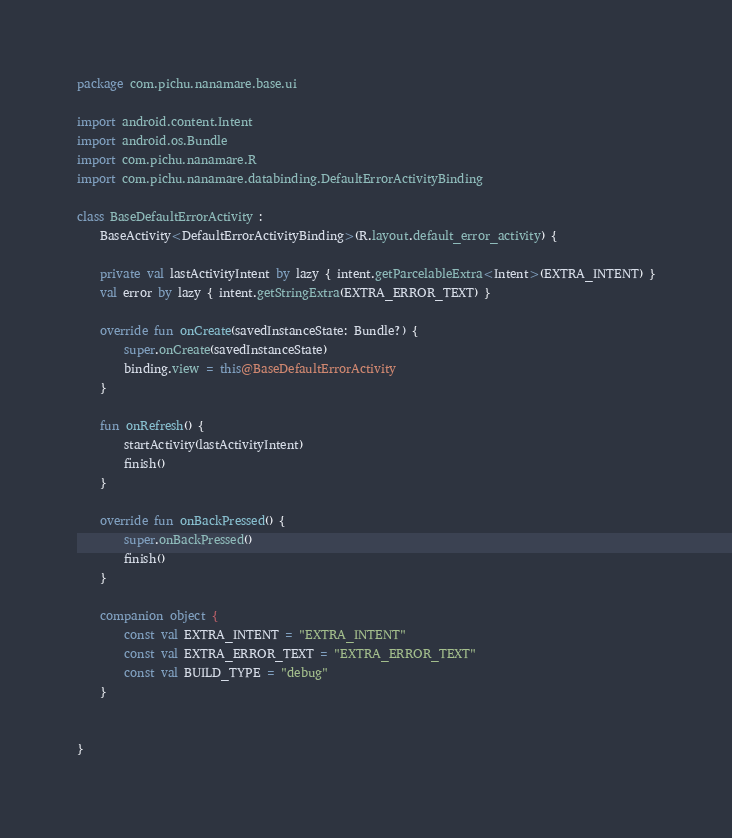<code> <loc_0><loc_0><loc_500><loc_500><_Kotlin_>package com.pichu.nanamare.base.ui

import android.content.Intent
import android.os.Bundle
import com.pichu.nanamare.R
import com.pichu.nanamare.databinding.DefaultErrorActivityBinding

class BaseDefaultErrorActivity :
    BaseActivity<DefaultErrorActivityBinding>(R.layout.default_error_activity) {

    private val lastActivityIntent by lazy { intent.getParcelableExtra<Intent>(EXTRA_INTENT) }
    val error by lazy { intent.getStringExtra(EXTRA_ERROR_TEXT) }

    override fun onCreate(savedInstanceState: Bundle?) {
        super.onCreate(savedInstanceState)
        binding.view = this@BaseDefaultErrorActivity
    }

    fun onRefresh() {
        startActivity(lastActivityIntent)
        finish()
    }

    override fun onBackPressed() {
        super.onBackPressed()
        finish()
    }

    companion object {
        const val EXTRA_INTENT = "EXTRA_INTENT"
        const val EXTRA_ERROR_TEXT = "EXTRA_ERROR_TEXT"
        const val BUILD_TYPE = "debug"
    }


}</code> 